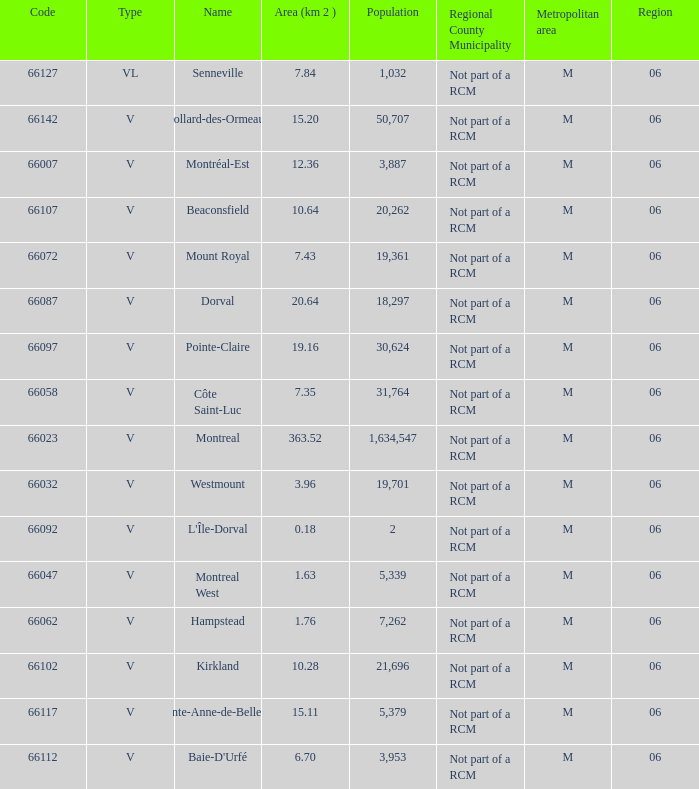What is the largest area with a Code of 66097, and a Region larger than 6? None. 